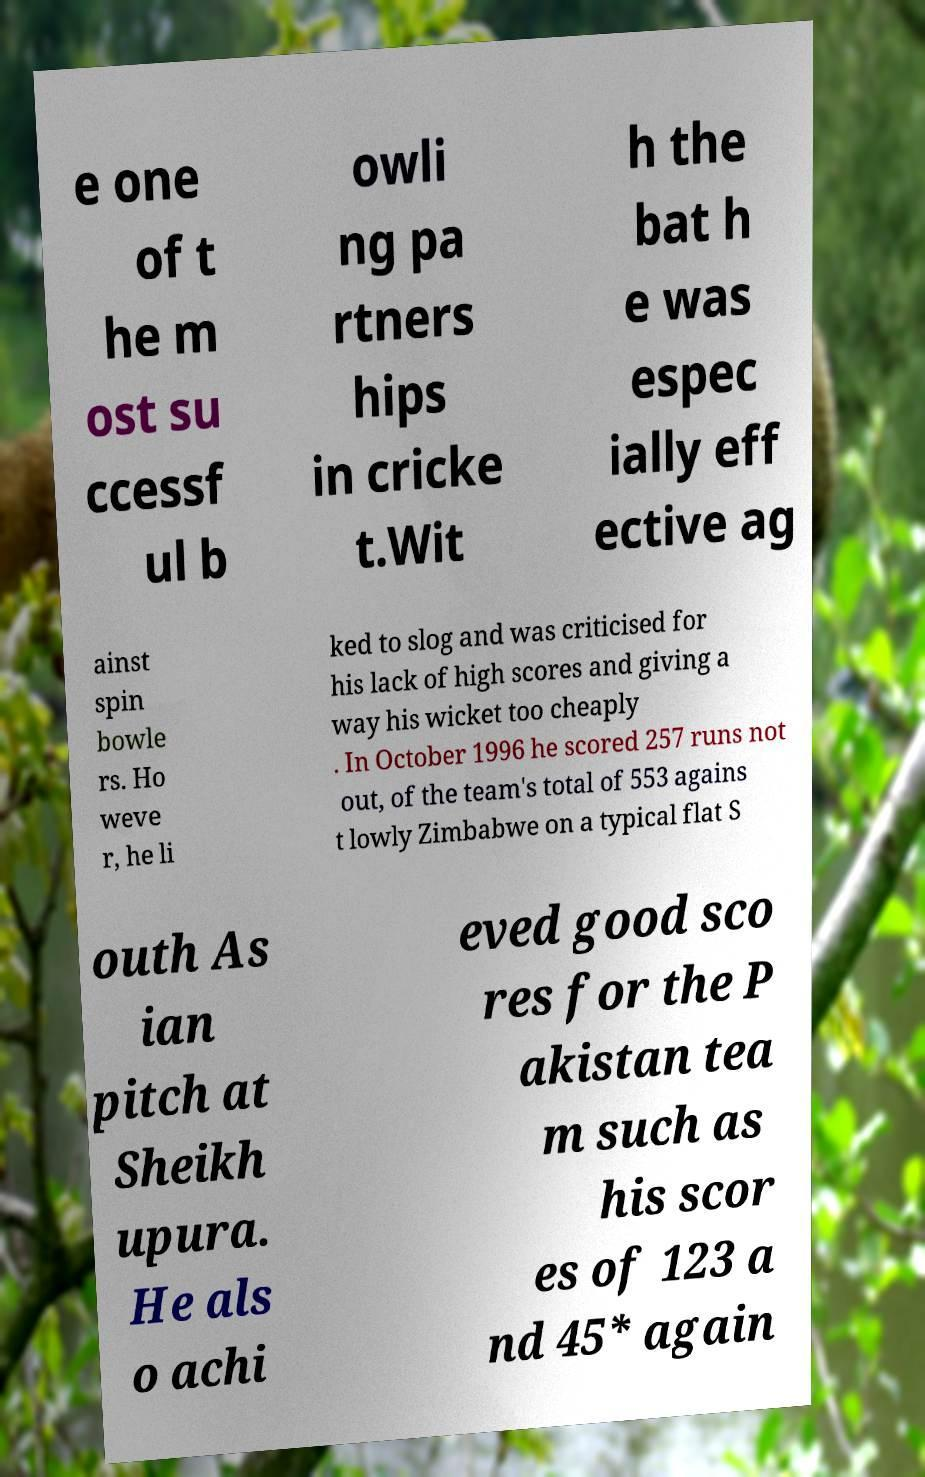Can you read and provide the text displayed in the image?This photo seems to have some interesting text. Can you extract and type it out for me? e one of t he m ost su ccessf ul b owli ng pa rtners hips in cricke t.Wit h the bat h e was espec ially eff ective ag ainst spin bowle rs. Ho weve r, he li ked to slog and was criticised for his lack of high scores and giving a way his wicket too cheaply . In October 1996 he scored 257 runs not out, of the team's total of 553 agains t lowly Zimbabwe on a typical flat S outh As ian pitch at Sheikh upura. He als o achi eved good sco res for the P akistan tea m such as his scor es of 123 a nd 45* again 